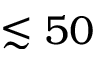Convert formula to latex. <formula><loc_0><loc_0><loc_500><loc_500>\lesssim 5 0</formula> 